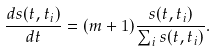<formula> <loc_0><loc_0><loc_500><loc_500>\frac { d s ( t , t _ { i } ) } { d t } = ( m + 1 ) \frac { s ( t , t _ { i } ) } { \sum _ { i } s ( t , t _ { i } ) } .</formula> 